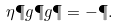Convert formula to latex. <formula><loc_0><loc_0><loc_500><loc_500>\eta \P g \P g \P = - \P .</formula> 